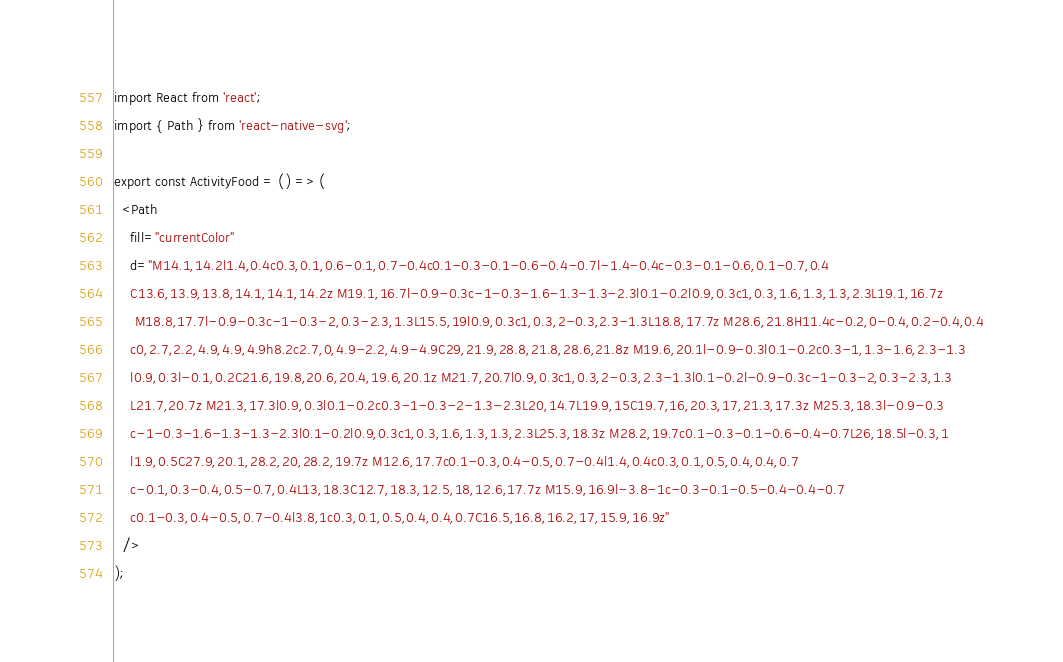<code> <loc_0><loc_0><loc_500><loc_500><_TypeScript_>import React from 'react';
import { Path } from 'react-native-svg';

export const ActivityFood = () => (
  <Path
    fill="currentColor"
    d="M14.1,14.2l1.4,0.4c0.3,0.1,0.6-0.1,0.7-0.4c0.1-0.3-0.1-0.6-0.4-0.7l-1.4-0.4c-0.3-0.1-0.6,0.1-0.7,0.4
	C13.6,13.9,13.8,14.1,14.1,14.2z M19.1,16.7l-0.9-0.3c-1-0.3-1.6-1.3-1.3-2.3l0.1-0.2l0.9,0.3c1,0.3,1.6,1.3,1.3,2.3L19.1,16.7z
	 M18.8,17.7l-0.9-0.3c-1-0.3-2,0.3-2.3,1.3L15.5,19l0.9,0.3c1,0.3,2-0.3,2.3-1.3L18.8,17.7z M28.6,21.8H11.4c-0.2,0-0.4,0.2-0.4,0.4
	c0,2.7,2.2,4.9,4.9,4.9h8.2c2.7,0,4.9-2.2,4.9-4.9C29,21.9,28.8,21.8,28.6,21.8z M19.6,20.1l-0.9-0.3l0.1-0.2c0.3-1,1.3-1.6,2.3-1.3
	l0.9,0.3l-0.1,0.2C21.6,19.8,20.6,20.4,19.6,20.1z M21.7,20.7l0.9,0.3c1,0.3,2-0.3,2.3-1.3l0.1-0.2l-0.9-0.3c-1-0.3-2,0.3-2.3,1.3
	L21.7,20.7z M21.3,17.3l0.9,0.3l0.1-0.2c0.3-1-0.3-2-1.3-2.3L20,14.7L19.9,15C19.7,16,20.3,17,21.3,17.3z M25.3,18.3l-0.9-0.3
	c-1-0.3-1.6-1.3-1.3-2.3l0.1-0.2l0.9,0.3c1,0.3,1.6,1.3,1.3,2.3L25.3,18.3z M28.2,19.7c0.1-0.3-0.1-0.6-0.4-0.7L26,18.5l-0.3,1
	l1.9,0.5C27.9,20.1,28.2,20,28.2,19.7z M12.6,17.7c0.1-0.3,0.4-0.5,0.7-0.4l1.4,0.4c0.3,0.1,0.5,0.4,0.4,0.7
	c-0.1,0.3-0.4,0.5-0.7,0.4L13,18.3C12.7,18.3,12.5,18,12.6,17.7z M15.9,16.9l-3.8-1c-0.3-0.1-0.5-0.4-0.4-0.7
	c0.1-0.3,0.4-0.5,0.7-0.4l3.8,1c0.3,0.1,0.5,0.4,0.4,0.7C16.5,16.8,16.2,17,15.9,16.9z"
  />
);
</code> 